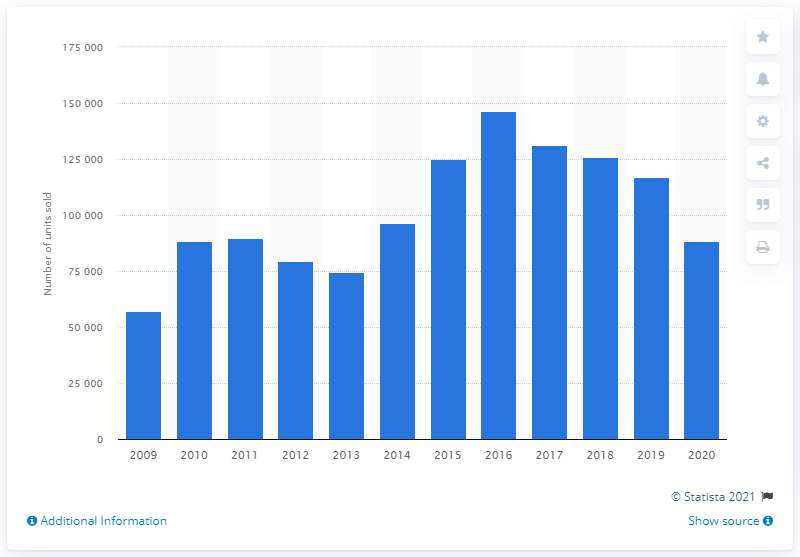Outline some significant characteristics in this image. In 2016, a total of 146,647 passenger cars were sold in Ireland. In 2020, a total of 8,832 passenger cars were sold in Ireland. 